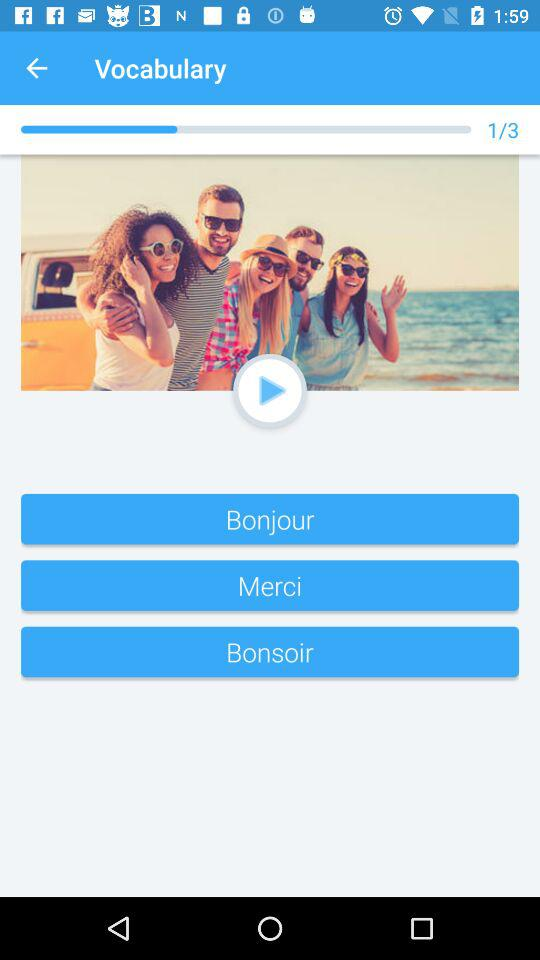What is the total number of questions? The total number of questions is 3. 